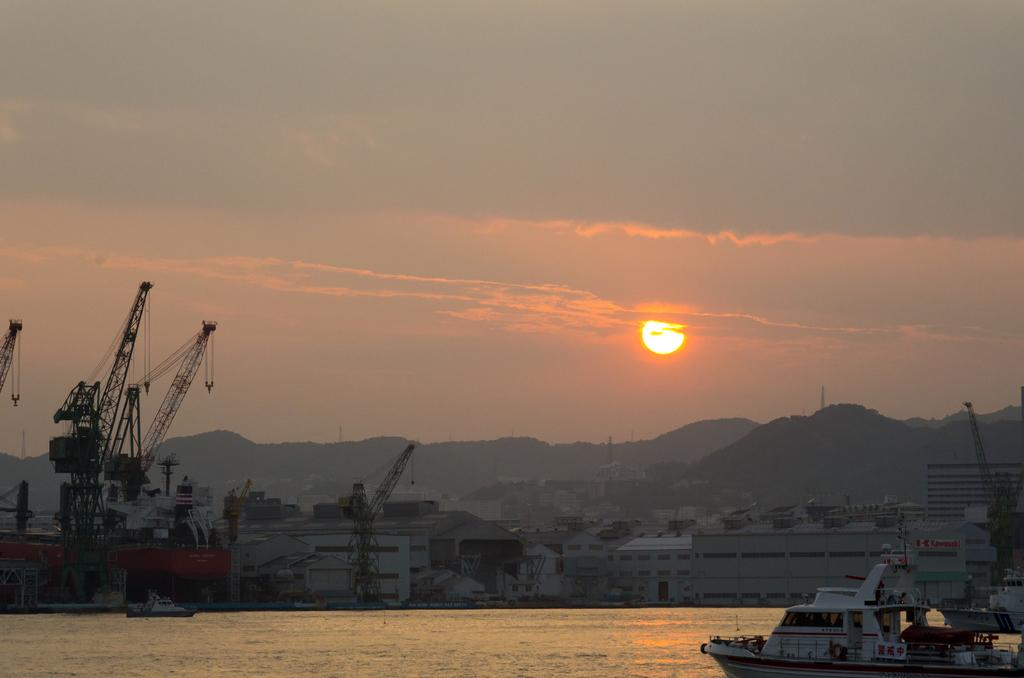What is located in the water in the image? There are ships in the water in the image. What type of structures can be seen in the image? There are cranes, towers, and buildings in the image. What natural features are visible in the image? There are mountains in the image. What celestial body is visible in the image? The sun is visible in the image. What else can be seen in the sky in the image? The sky is visible in the image. Where is the plastic market located in the image? There is no plastic market present in the image. What type of error can be seen in the image? There is no error present in the image. 